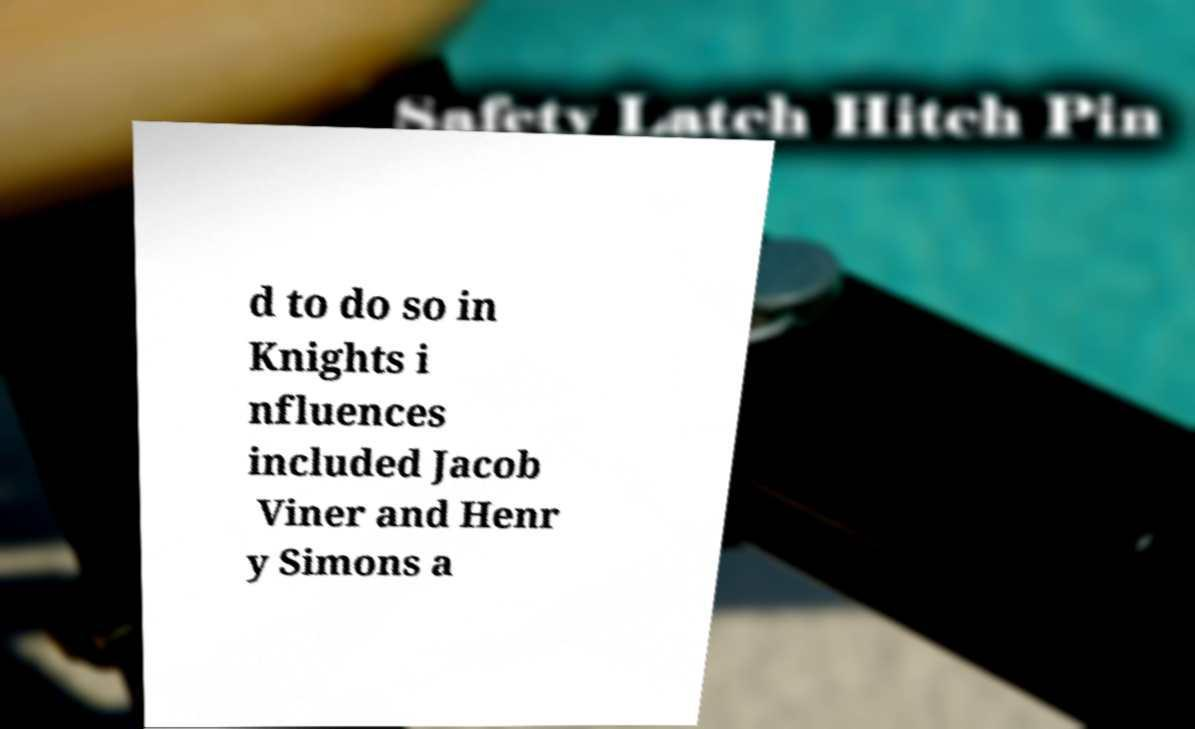Please read and relay the text visible in this image. What does it say? d to do so in Knights i nfluences included Jacob Viner and Henr y Simons a 